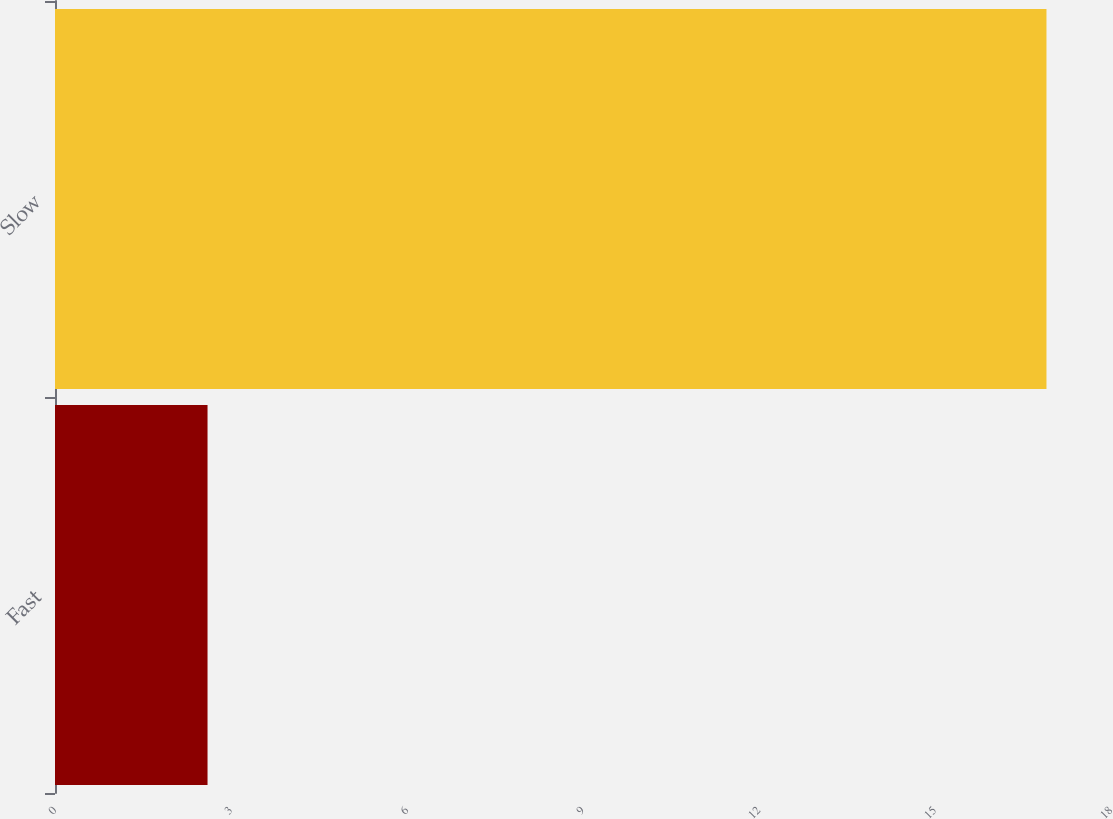Convert chart. <chart><loc_0><loc_0><loc_500><loc_500><bar_chart><fcel>Fast<fcel>Slow<nl><fcel>2.6<fcel>16.9<nl></chart> 